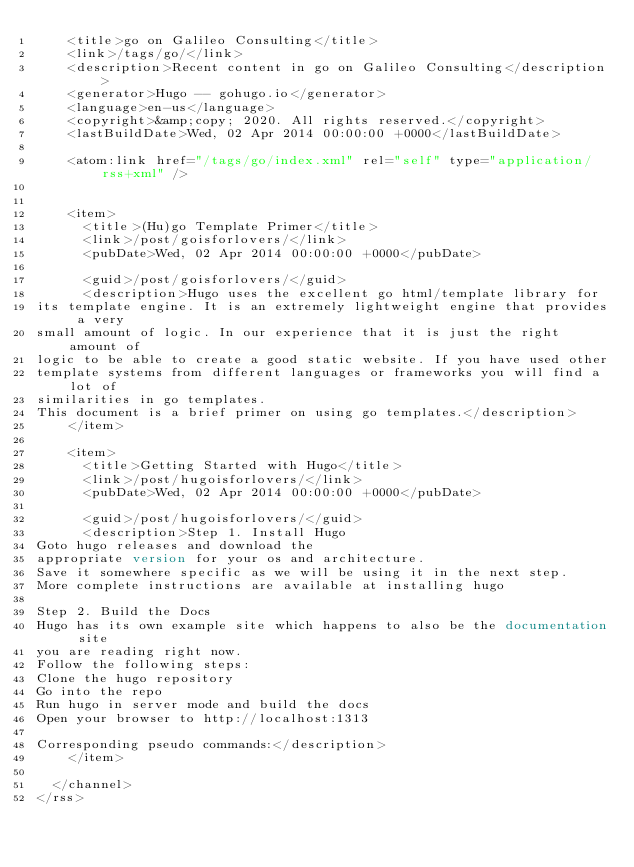Convert code to text. <code><loc_0><loc_0><loc_500><loc_500><_XML_>    <title>go on Galileo Consulting</title>
    <link>/tags/go/</link>
    <description>Recent content in go on Galileo Consulting</description>
    <generator>Hugo -- gohugo.io</generator>
    <language>en-us</language>
    <copyright>&amp;copy; 2020. All rights reserved.</copyright>
    <lastBuildDate>Wed, 02 Apr 2014 00:00:00 +0000</lastBuildDate>
    
	<atom:link href="/tags/go/index.xml" rel="self" type="application/rss+xml" />
    
    
    <item>
      <title>(Hu)go Template Primer</title>
      <link>/post/goisforlovers/</link>
      <pubDate>Wed, 02 Apr 2014 00:00:00 +0000</pubDate>
      
      <guid>/post/goisforlovers/</guid>
      <description>Hugo uses the excellent go html/template library forits template engine. It is an extremely lightweight engine that provides a verysmall amount of logic. In our experience that it is just the right amount oflogic to be able to create a good static website. If you have used othertemplate systems from different languages or frameworks you will find a lot ofsimilarities in go templates.
This document is a brief primer on using go templates.</description>
    </item>
    
    <item>
      <title>Getting Started with Hugo</title>
      <link>/post/hugoisforlovers/</link>
      <pubDate>Wed, 02 Apr 2014 00:00:00 +0000</pubDate>
      
      <guid>/post/hugoisforlovers/</guid>
      <description>Step 1. Install HugoGoto hugo releases and download theappropriate version for your os and architecture.
Save it somewhere specific as we will be using it in the next step.
More complete instructions are available at installing hugo
Step 2. Build the DocsHugo has its own example site which happens to also be the documentation siteyou are reading right now.
Follow the following steps:
Clone the hugo repositoryGo into the repoRun hugo in server mode and build the docsOpen your browser to http://localhost:1313Corresponding pseudo commands:</description>
    </item>
    
  </channel>
</rss></code> 